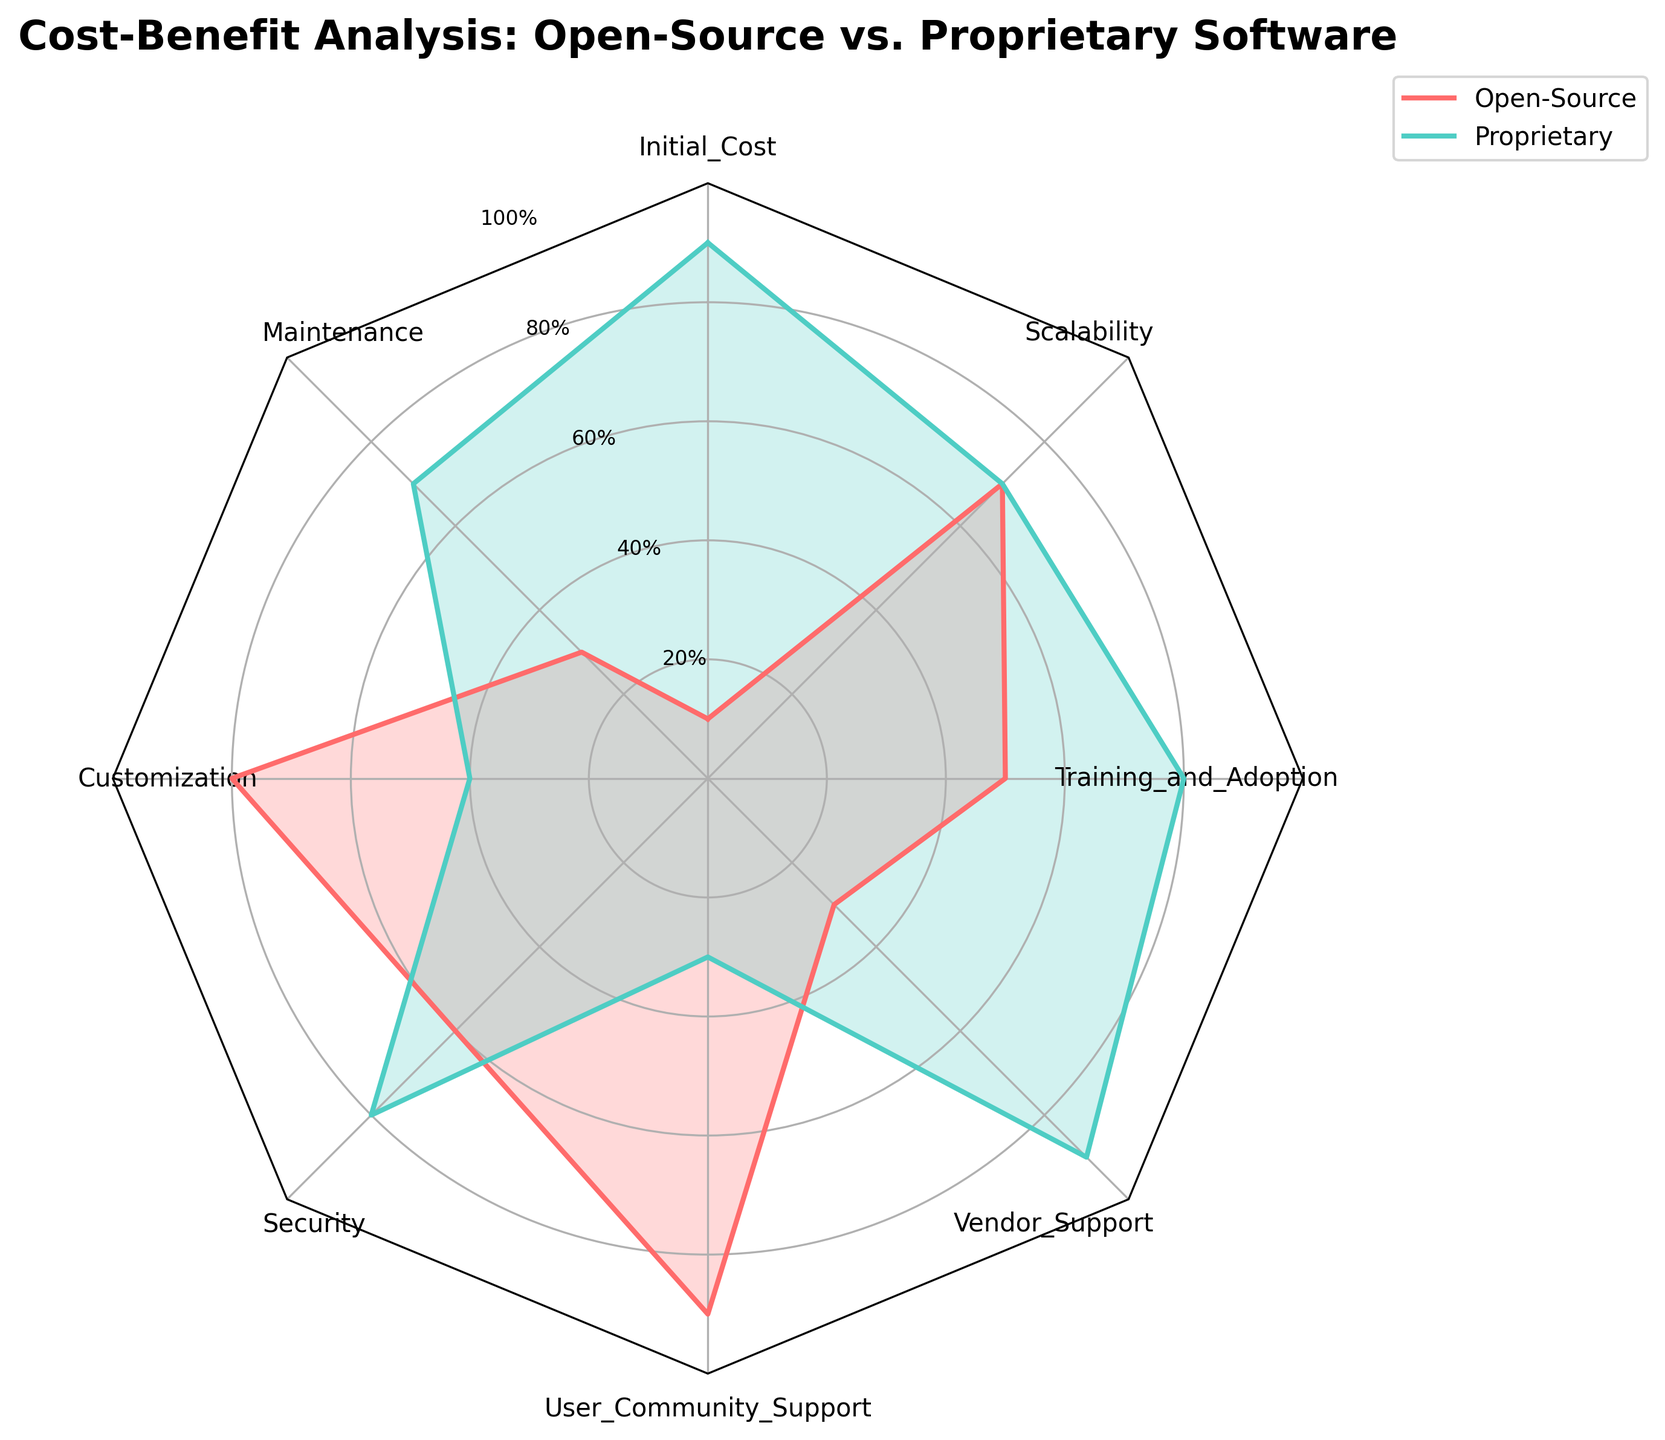Which category has the highest score for Open-Source software? To find the highest score for Open-Source software, look at each category and compare the numerical values. The highest value among Open-Source categories is 90 for "User Community Support".
Answer: User Community Support What is the average score for Security across both Open-Source and Proprietary software? Add the scores for Security (Open-Source: 60, Proprietary: 80) and divide by 2: (60 + 80) / 2 = 70.
Answer: 70 Which software type has better initial cost efficiency? Compare the "Initial_Cost" values for both software types. Open-Source has 10 and Proprietary has 90. Lower values are better for cost efficiency, so Open-Source is more cost-efficient.
Answer: Open-Source How do Open-Source and Proprietary software compare in terms of scalability? Look at the "Scalability" category values for both software types. Both Open-Source and Proprietary have the same score of 70.
Answer: The same Which categories show a higher score for Open-Source software than Proprietary software? Compare the values for each category. Open-Source scores higher in the categories: Customization (80 vs. 40), User Community Support (90 vs. 30), and Training and Adoption (50 vs. 80).
Answer: Customization, User Community Support In which category do Proprietary software outperform Open-Source the most? We need to compare the scores for each category and find out where the Proprietary software has the highest advantage. The highest difference in favor of Proprietary is in "Vendor Support" with a score of 90 compared to 30 for Open-Source.
Answer: Vendor Support What are the two categories where Open-Source and Proprietary software have the same score? Check for categories where the scores for Open-Source and Proprietary are equal. The "Scalability" category has the same score for both Open-Source and Proprietary software at 70. There are no other categories with the same score.
Answer: Scalability 